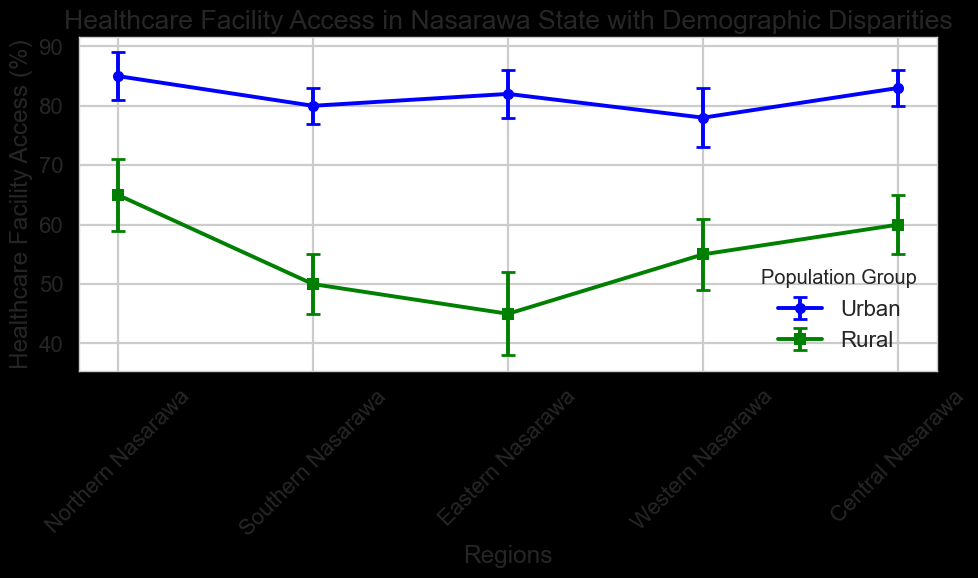What is the healthcare facility access percentage for Urban populations in Northern Nasarawa? The figure displays different regions along with their urban and rural healthcare facility access percentages. Locate the Urban group for Northern Nasarawa.
Answer: 85 Compare the healthcare facility access between Urban and Rural populations in Western Nasarawa. Western Nasarawa has two groups: Urban and Rural. On the figure, find the access rates for these two groups and compare them.
Answer: Urban: 78%, Rural: 55% Which region has the lowest healthcare facility access for Rural populations? Find the Rural populations' access percentages across all regions and identify the lowest value.
Answer: Eastern Nasarawa What is the average healthcare facility access for Urban populations across all regions? Locate the healthcare facility access percentages for Urban populations in each region: Northern Nasarawa (85%), Southern Nasarawa (80%), Eastern Nasarawa (82%), Western Nasarawa (78%), Central Nasarawa (83%). Calculate the average: (85 + 80 + 82 + 78 + 83) / 5 = 81.6
Answer: 81.6 How much higher is the healthcare facility access for Urban populations compared to Rural populations in Central Nasarawa? Find the healthcare facility access percentages for both Urban (83%) and Rural (60%) populations in Central Nasarawa. Subtract the Rural percentage from the Urban percentage: 83% - 60% = 23%
Answer: 23% Identify the region with the smallest error margin for Rural populations. Review the figure for the error margins of Rural populations in each region. The smallest margin is for Southern Nasarawa (5%).
Answer: Southern Nasarawa What is the combined healthcare facility access percentage for Rural populations in both Northern and Southern Nasarawa? Add the healthcare facility access percentages for Rural populations in Northern Nasarawa (65%) and Southern Nasarawa (50%). 65 + 50 = 115
Answer: 115 Is the healthcare facility access for the Urban population in Southern Nasarawa higher or lower compared to the Urban population in Eastern Nasarawa? Compare the Urban access percentages for Southern Nasarawa (80%) and Eastern Nasarawa (82%).
Answer: Lower Which population group (Urban or Rural) exhibits greater variability in their access percentages across all regions? Evaluate the differences across all regions for Urban and Rural groups. Calculate the range (max - min) for each group: Urban (85-78=7) and Rural (65-45=20).
Answer: Rural What’s the combined error margin for Urban populations in Northern Nasarawa and Rural populations in Western Nasarawa? Summing the error margins for Urban (4%) in Northern Nasarawa and Rural (6%) in Western Nasarawa: 4 + 6 = 10
Answer: 10 